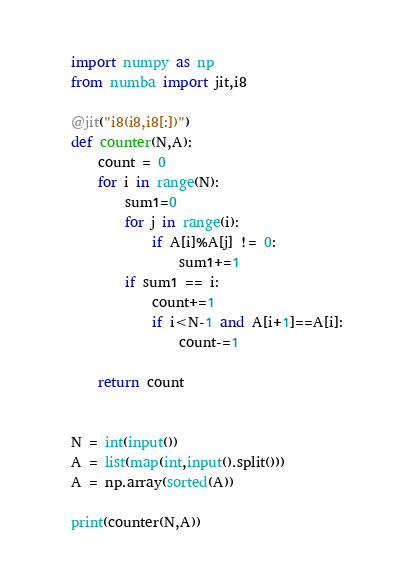<code> <loc_0><loc_0><loc_500><loc_500><_Python_>import numpy as np
from numba import jit,i8

@jit("i8(i8,i8[:])")
def counter(N,A):
    count = 0
    for i in range(N):
        sum1=0
        for j in range(i):
            if A[i]%A[j] != 0:
                sum1+=1
        if sum1 == i:
            count+=1
            if i<N-1 and A[i+1]==A[i]:
                count-=1

    return count
    
    
N = int(input())
A = list(map(int,input().split()))
A = np.array(sorted(A))

print(counter(N,A))</code> 